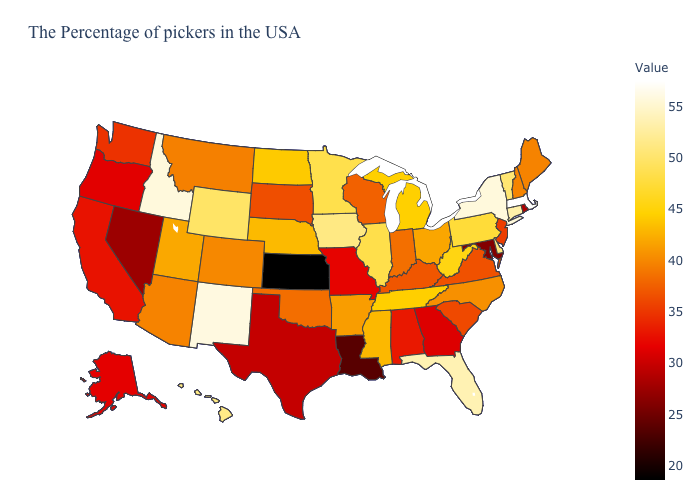Among the states that border Florida , which have the lowest value?
Write a very short answer. Georgia. Which states have the highest value in the USA?
Short answer required. Massachusetts. Which states have the highest value in the USA?
Be succinct. Massachusetts. Does New Jersey have the highest value in the USA?
Give a very brief answer. No. Does North Dakota have a lower value than Wisconsin?
Be succinct. No. 